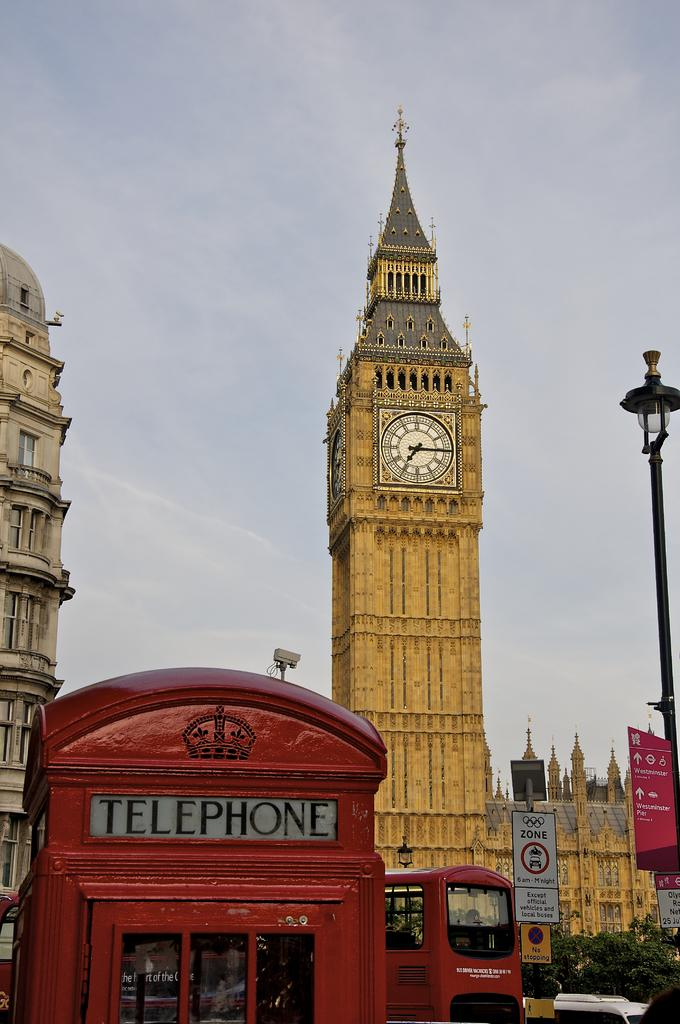What structure is located at the bottom of the image? There is a telephone booth at the bottom of the image. What else can be seen in the image besides the telephone booth? Vehicles, boards attached to poles, trees, buildings in the background, and a clock mounted on a wall in the background are visible in the image. What is the weather like in the image? Clouds are visible in the sky, indicating that it might be a partly cloudy day. What type of corn can be seen growing in the playground in the image? There is no playground or corn present in the image. 